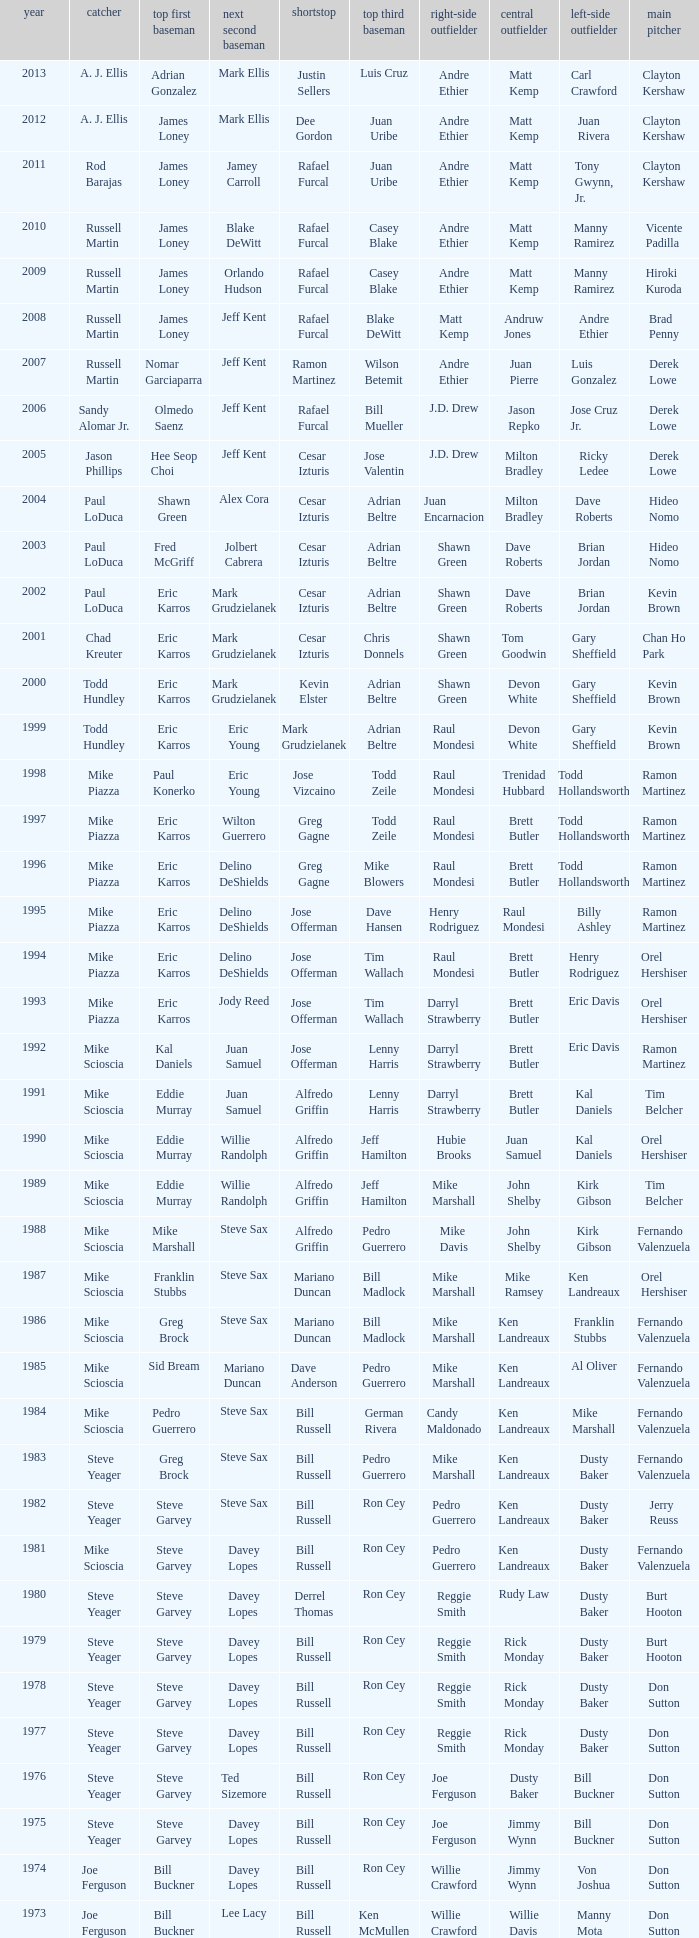Who played SS when paul konerko played 1st base? Jose Vizcaino. 